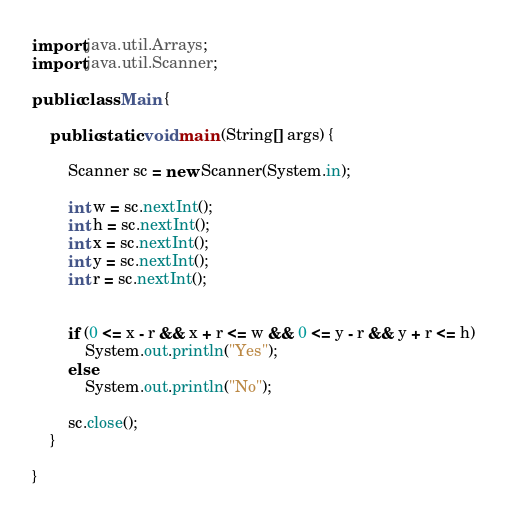Convert code to text. <code><loc_0><loc_0><loc_500><loc_500><_Java_>import java.util.Arrays;
import java.util.Scanner;

public class Main {

	public static void main (String[] args) {

		Scanner sc = new Scanner(System.in);
		
		int w = sc.nextInt();
		int h = sc.nextInt();
		int x = sc.nextInt();
		int y = sc.nextInt();
		int r = sc.nextInt();
		
		
		if (0 <= x - r && x + r <= w && 0 <= y - r && y + r <= h)
			System.out.println("Yes");
		else
			System.out.println("No");
		
		sc.close();
	}

}</code> 